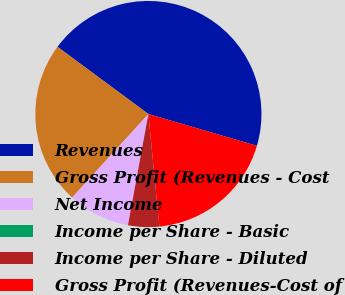Convert chart. <chart><loc_0><loc_0><loc_500><loc_500><pie_chart><fcel>Revenues<fcel>Gross Profit (Revenues - Cost<fcel>Net Income<fcel>Income per Share - Basic<fcel>Income per Share - Diluted<fcel>Gross Profit (Revenues-Cost of<nl><fcel>44.4%<fcel>23.36%<fcel>8.88%<fcel>0.0%<fcel>4.44%<fcel>18.92%<nl></chart> 